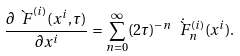Convert formula to latex. <formula><loc_0><loc_0><loc_500><loc_500>\frac { \partial \grave { \ F } ^ { ( i ) } ( x ^ { i } , \tau ) } { \partial x ^ { i } } = \sum _ { n = 0 } ^ { \infty } ( 2 \tau ) ^ { - n } \dot { \grave { \ F } } ^ { ( i ) } _ { n } ( x ^ { i } ) .</formula> 